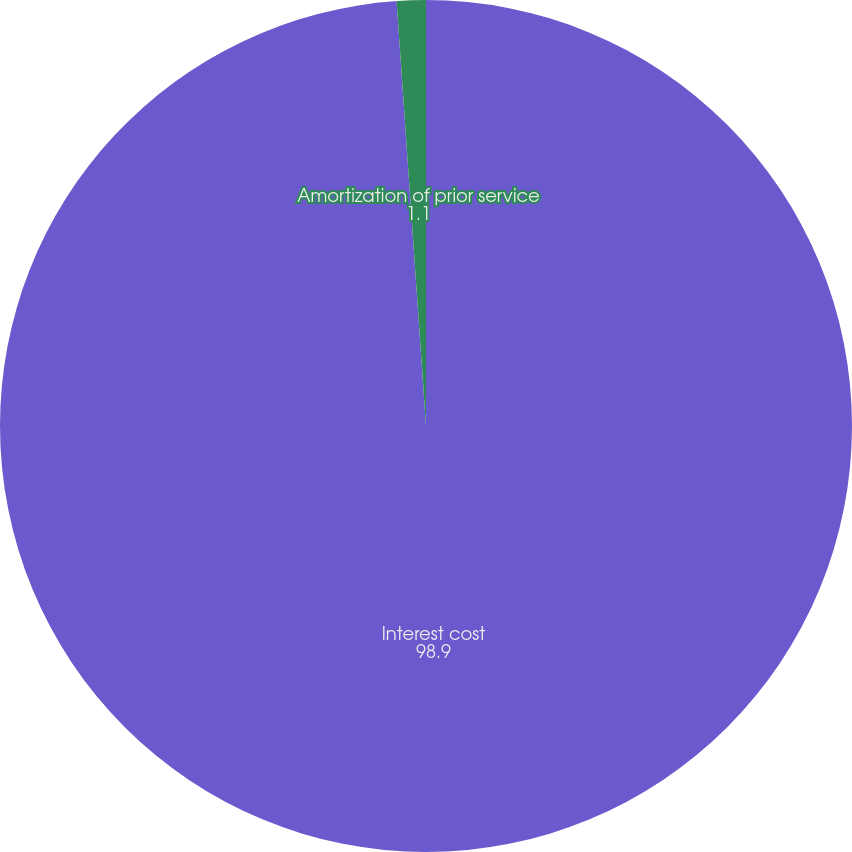Convert chart. <chart><loc_0><loc_0><loc_500><loc_500><pie_chart><fcel>Interest cost<fcel>Amortization of prior service<nl><fcel>98.9%<fcel>1.1%<nl></chart> 